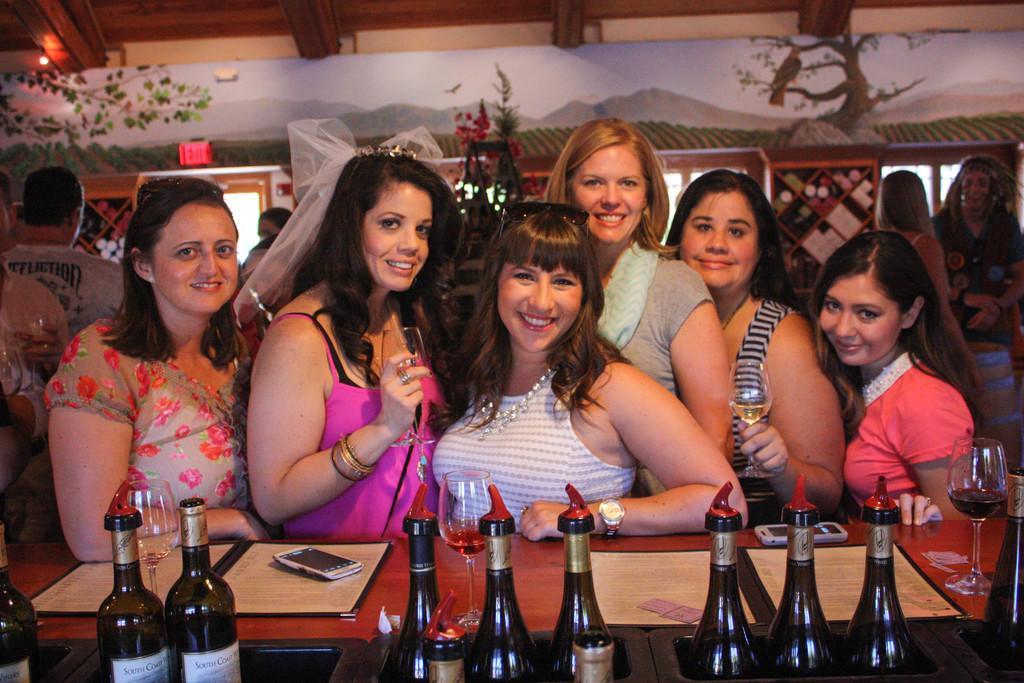Please provide a concise description of this image. In this picture we can see a group of woman standing and smiling and in front of them we have mobile, menu cards, remote, bottles, glass drink in it on table and in background we can see wall with painting. 